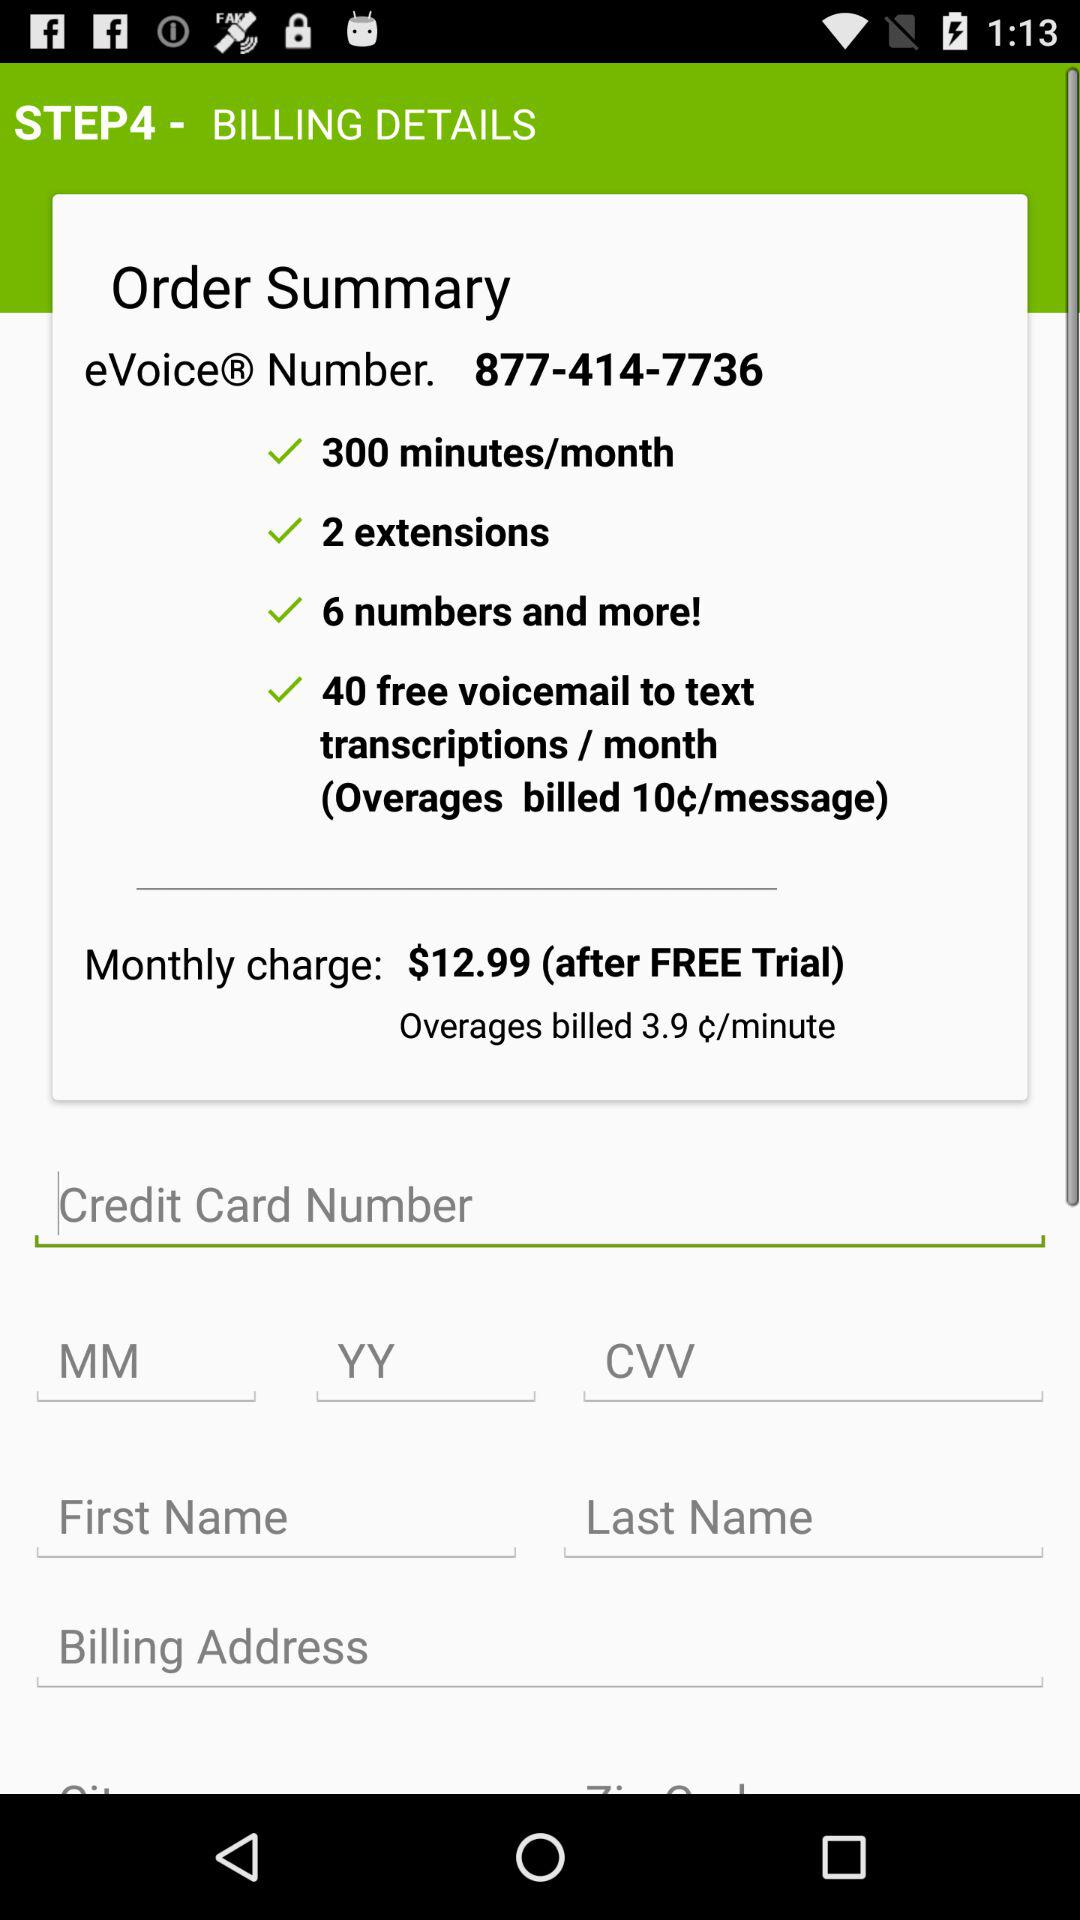What is the monthly charge? The monthly charge is $12.99. 